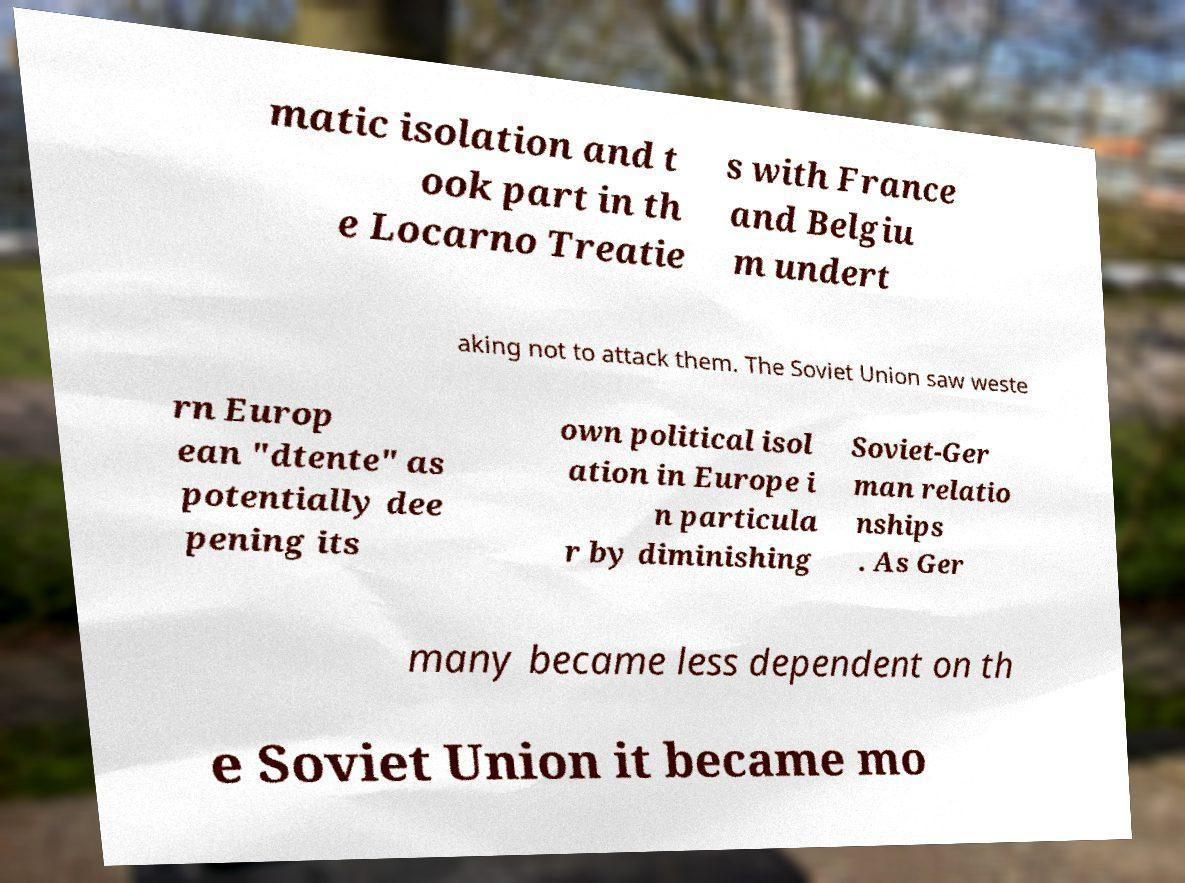Could you extract and type out the text from this image? matic isolation and t ook part in th e Locarno Treatie s with France and Belgiu m undert aking not to attack them. The Soviet Union saw weste rn Europ ean "dtente" as potentially dee pening its own political isol ation in Europe i n particula r by diminishing Soviet-Ger man relatio nships . As Ger many became less dependent on th e Soviet Union it became mo 